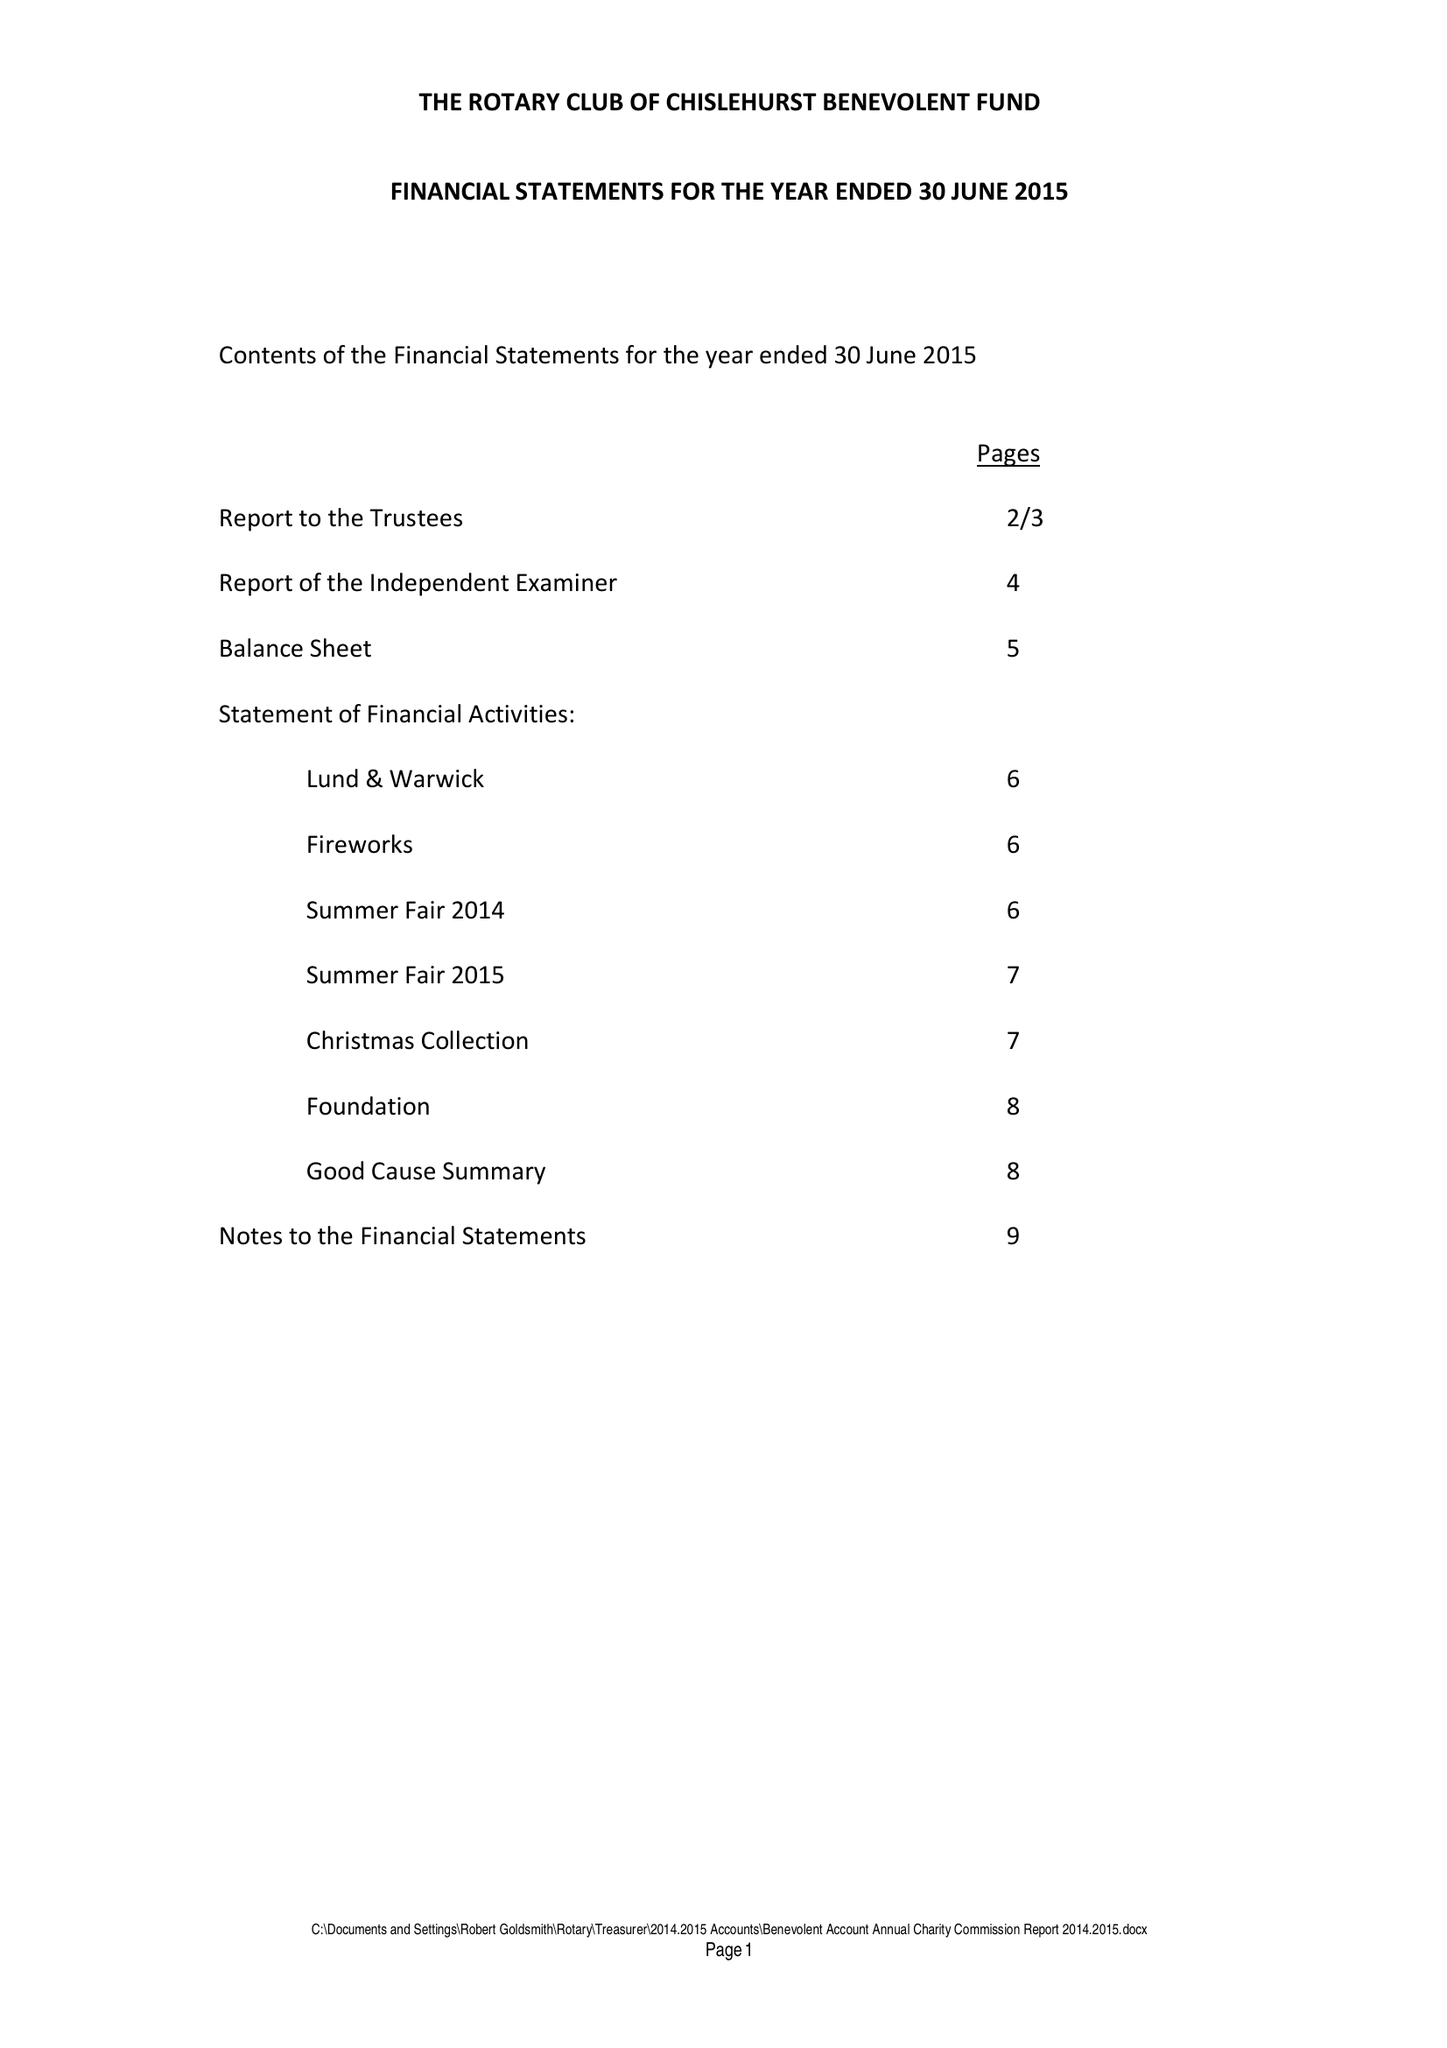What is the value for the charity_name?
Answer the question using a single word or phrase. The Rotary Club Of Chislehurst Benevolent Fund 